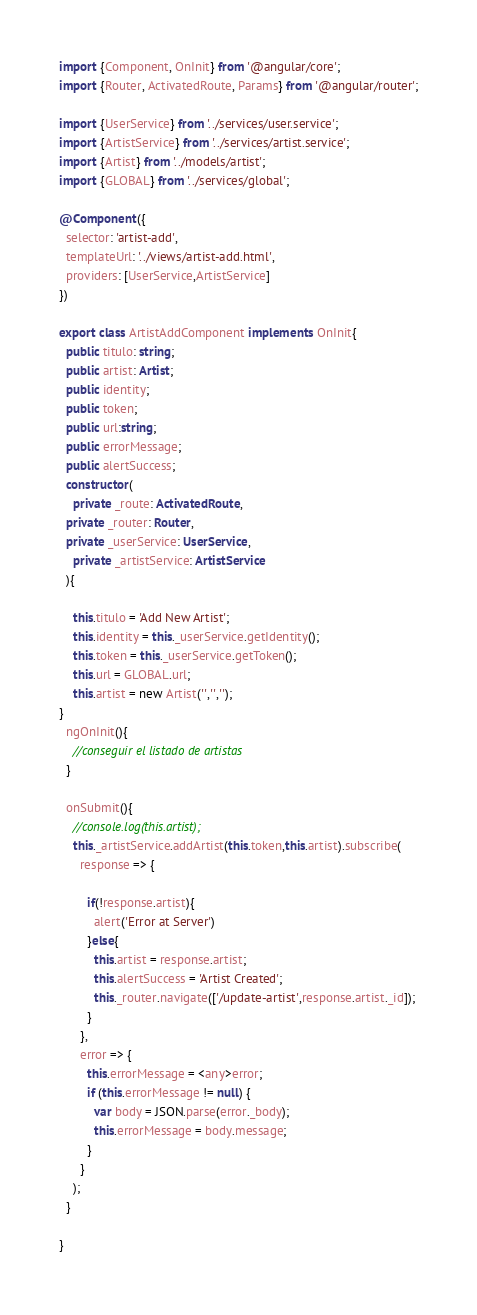Convert code to text. <code><loc_0><loc_0><loc_500><loc_500><_TypeScript_>import {Component, OnInit} from '@angular/core';
import {Router, ActivatedRoute, Params} from '@angular/router';

import {UserService} from '../services/user.service';
import {ArtistService} from '../services/artist.service';
import {Artist} from '../models/artist';
import {GLOBAL} from '../services/global';

@Component({
  selector: 'artist-add',
  templateUrl: '../views/artist-add.html',
  providers: [UserService,ArtistService]
})

export class ArtistAddComponent implements OnInit{
  public titulo: string;
  public artist: Artist;
  public identity;
  public token;
  public url:string;
  public errorMessage;
  public alertSuccess;
  constructor(
    private _route: ActivatedRoute,
  private _router: Router,
  private _userService: UserService,
    private _artistService: ArtistService
  ){

    this.titulo = 'Add New Artist';
    this.identity = this._userService.getIdentity();
    this.token = this._userService.getToken();
    this.url = GLOBAL.url;
    this.artist = new Artist('','','');
}
  ngOnInit(){
    //conseguir el listado de artistas
  }

  onSubmit(){
    //console.log(this.artist);
    this._artistService.addArtist(this.token,this.artist).subscribe(
      response => {

        if(!response.artist){
          alert('Error at Server')
        }else{
          this.artist = response.artist;
          this.alertSuccess = 'Artist Created';
          this._router.navigate(['/update-artist',response.artist._id]);
        }
      },
      error => {
        this.errorMessage = <any>error;
        if (this.errorMessage != null) {
          var body = JSON.parse(error._body);
          this.errorMessage = body.message;
        }
      }
    );
  }

}
</code> 